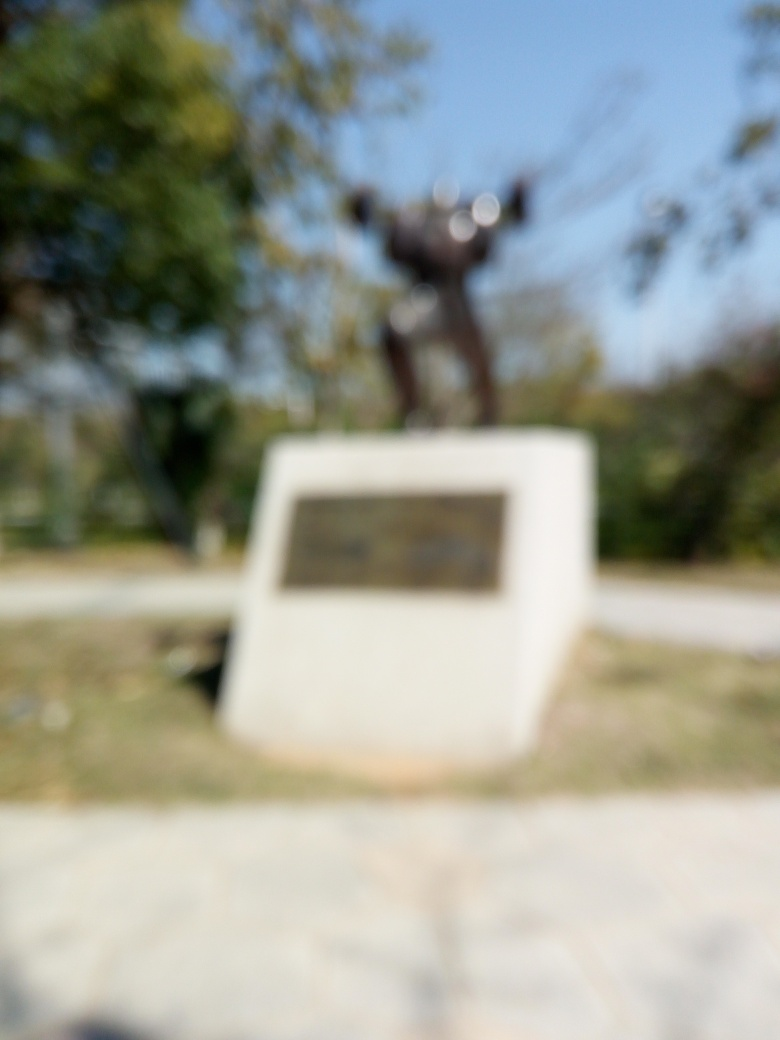Can you guess the time of day or the season when this photo was taken? Despite the image's blurriness, the brightness and the shadows suggest it could be midday. There's no evidence of wet surfaces or snow that might indicate specific seasons, but the presence of leaves on the trees might suggest it's taken during a warmer season, possibly spring or summer. 